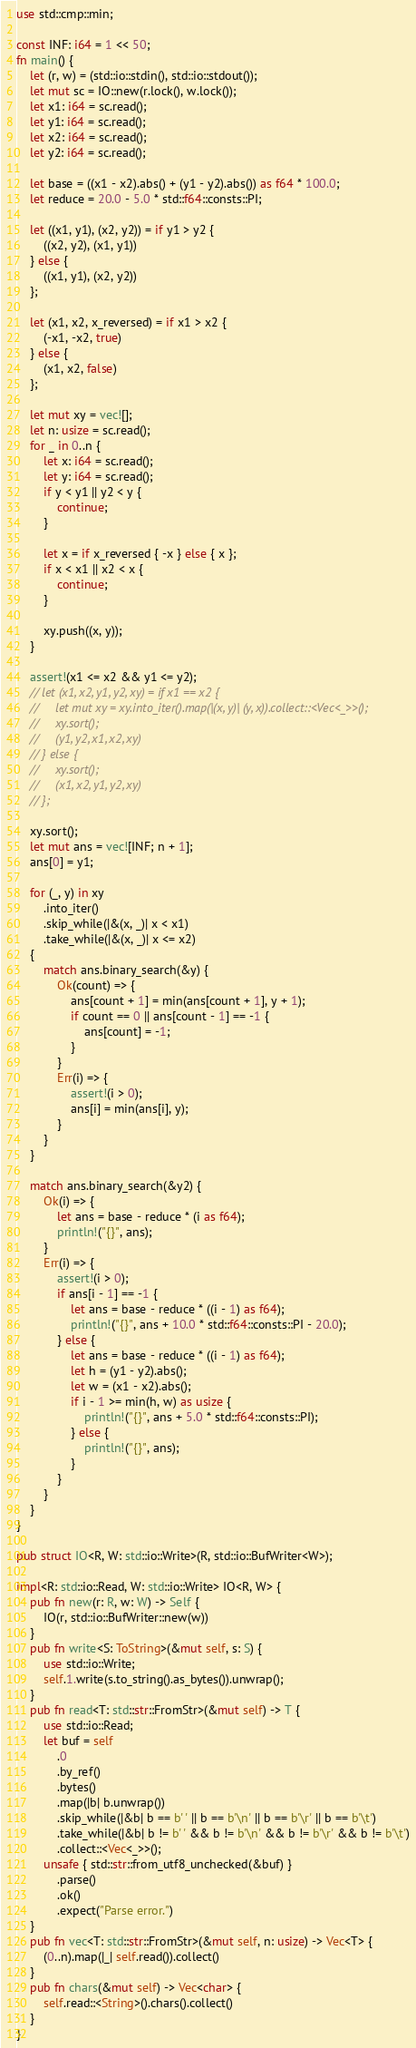Convert code to text. <code><loc_0><loc_0><loc_500><loc_500><_Rust_>use std::cmp::min;

const INF: i64 = 1 << 50;
fn main() {
    let (r, w) = (std::io::stdin(), std::io::stdout());
    let mut sc = IO::new(r.lock(), w.lock());
    let x1: i64 = sc.read();
    let y1: i64 = sc.read();
    let x2: i64 = sc.read();
    let y2: i64 = sc.read();

    let base = ((x1 - x2).abs() + (y1 - y2).abs()) as f64 * 100.0;
    let reduce = 20.0 - 5.0 * std::f64::consts::PI;

    let ((x1, y1), (x2, y2)) = if y1 > y2 {
        ((x2, y2), (x1, y1))
    } else {
        ((x1, y1), (x2, y2))
    };

    let (x1, x2, x_reversed) = if x1 > x2 {
        (-x1, -x2, true)
    } else {
        (x1, x2, false)
    };

    let mut xy = vec![];
    let n: usize = sc.read();
    for _ in 0..n {
        let x: i64 = sc.read();
        let y: i64 = sc.read();
        if y < y1 || y2 < y {
            continue;
        }

        let x = if x_reversed { -x } else { x };
        if x < x1 || x2 < x {
            continue;
        }

        xy.push((x, y));
    }

    assert!(x1 <= x2 && y1 <= y2);
    // let (x1, x2, y1, y2, xy) = if x1 == x2 {
    //     let mut xy = xy.into_iter().map(|(x, y)| (y, x)).collect::<Vec<_>>();
    //     xy.sort();
    //     (y1, y2, x1, x2, xy)
    // } else {
    //     xy.sort();
    //     (x1, x2, y1, y2, xy)
    // };

    xy.sort();
    let mut ans = vec![INF; n + 1];
    ans[0] = y1;

    for (_, y) in xy
        .into_iter()
        .skip_while(|&(x, _)| x < x1)
        .take_while(|&(x, _)| x <= x2)
    {
        match ans.binary_search(&y) {
            Ok(count) => {
                ans[count + 1] = min(ans[count + 1], y + 1);
                if count == 0 || ans[count - 1] == -1 {
                    ans[count] = -1;
                }
            }
            Err(i) => {
                assert!(i > 0);
                ans[i] = min(ans[i], y);
            }
        }
    }

    match ans.binary_search(&y2) {
        Ok(i) => {
            let ans = base - reduce * (i as f64);
            println!("{}", ans);
        }
        Err(i) => {
            assert!(i > 0);
            if ans[i - 1] == -1 {
                let ans = base - reduce * ((i - 1) as f64);
                println!("{}", ans + 10.0 * std::f64::consts::PI - 20.0);
            } else {
                let ans = base - reduce * ((i - 1) as f64);
                let h = (y1 - y2).abs();
                let w = (x1 - x2).abs();
                if i - 1 >= min(h, w) as usize {
                    println!("{}", ans + 5.0 * std::f64::consts::PI);
                } else {
                    println!("{}", ans);
                }
            }
        }
    }
}

pub struct IO<R, W: std::io::Write>(R, std::io::BufWriter<W>);

impl<R: std::io::Read, W: std::io::Write> IO<R, W> {
    pub fn new(r: R, w: W) -> Self {
        IO(r, std::io::BufWriter::new(w))
    }
    pub fn write<S: ToString>(&mut self, s: S) {
        use std::io::Write;
        self.1.write(s.to_string().as_bytes()).unwrap();
    }
    pub fn read<T: std::str::FromStr>(&mut self) -> T {
        use std::io::Read;
        let buf = self
            .0
            .by_ref()
            .bytes()
            .map(|b| b.unwrap())
            .skip_while(|&b| b == b' ' || b == b'\n' || b == b'\r' || b == b'\t')
            .take_while(|&b| b != b' ' && b != b'\n' && b != b'\r' && b != b'\t')
            .collect::<Vec<_>>();
        unsafe { std::str::from_utf8_unchecked(&buf) }
            .parse()
            .ok()
            .expect("Parse error.")
    }
    pub fn vec<T: std::str::FromStr>(&mut self, n: usize) -> Vec<T> {
        (0..n).map(|_| self.read()).collect()
    }
    pub fn chars(&mut self) -> Vec<char> {
        self.read::<String>().chars().collect()
    }
}
</code> 